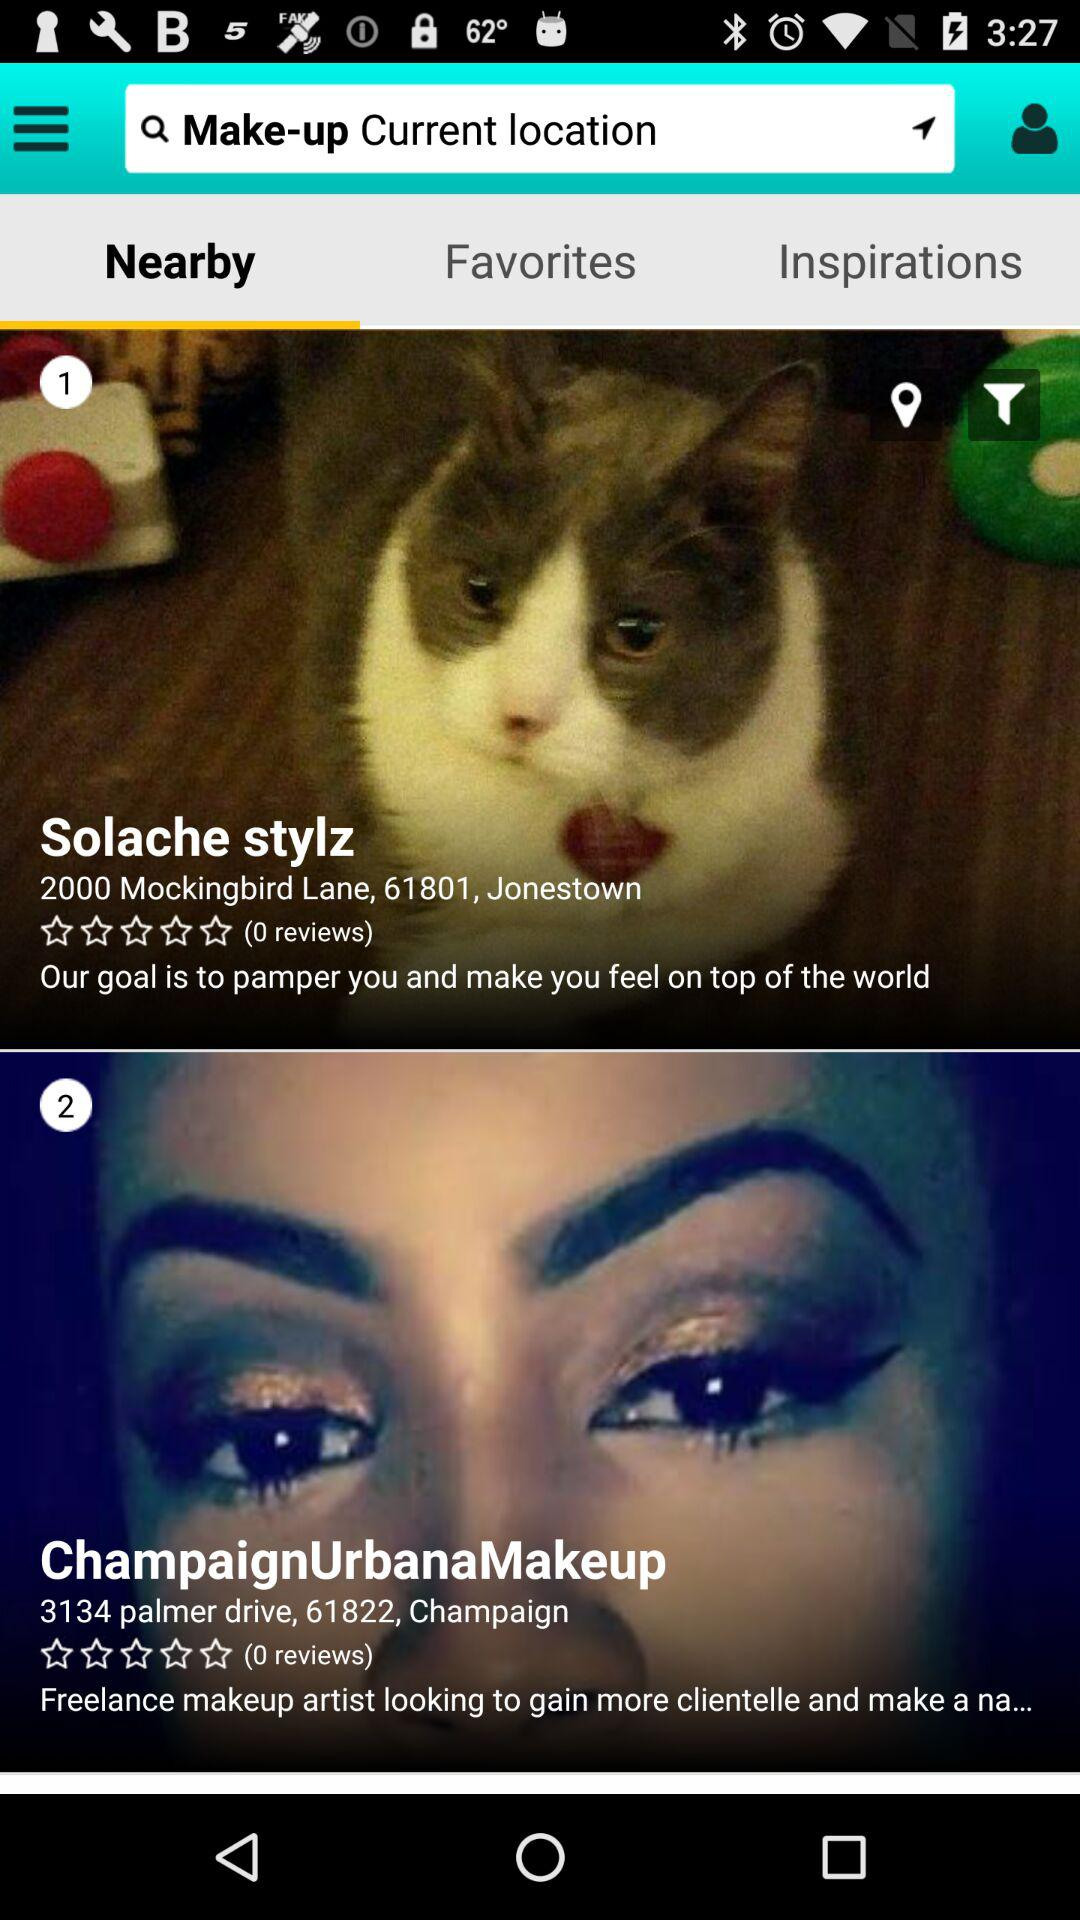What is the address of "ChampaignUrbanaMakeup"? The address is 3134 palmer drive, 61822, Champaign. 